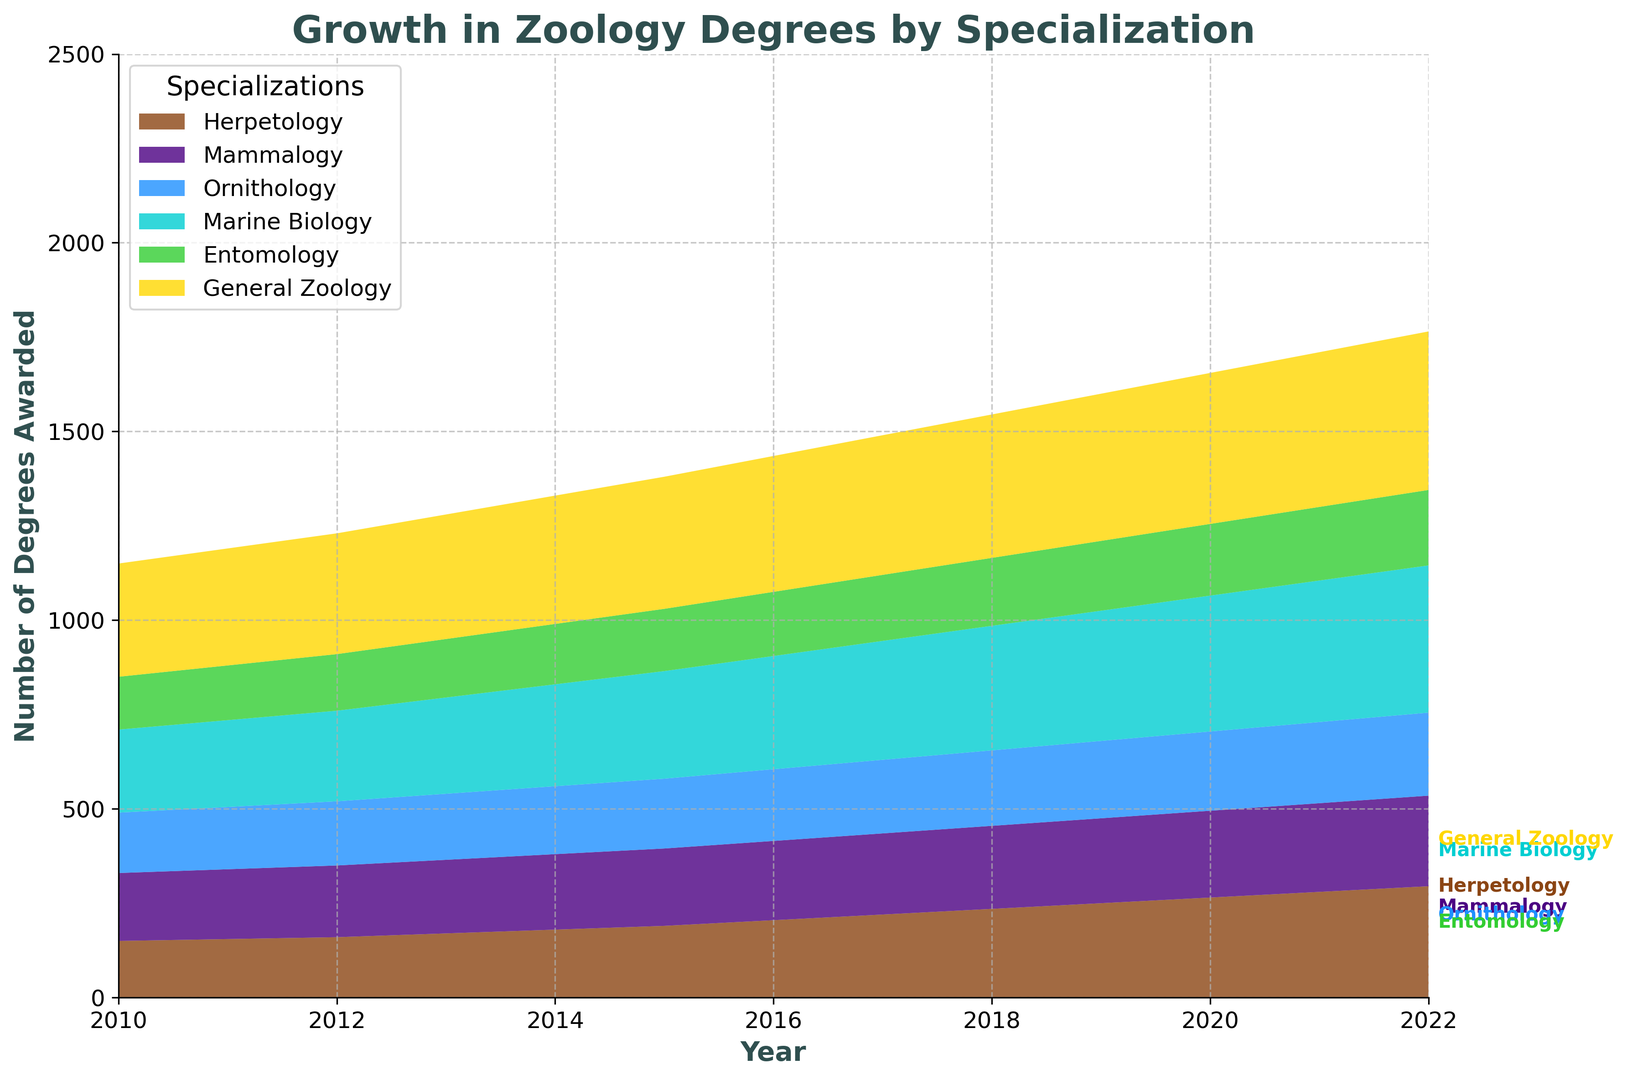What's the total number of degrees awarded in 2022 across all specializations? First, find the values for each specialization in 2022: Herpetology (295), Mammalogy (240), Ornithology (220), Marine Biology (390), Entomology (200), General Zoology (420). Sum these values: 295 + 240 + 220 + 390 + 200 + 420 = 1765
Answer: 1765 Which specialization showed the most significant growth from 2010 to 2022? Calculate the difference between the values in 2022 and 2010 for each specialization: Herpetology (295-150=145), Mammalogy (240-180=60), Ornithology (220-160=60), Marine Biology (390-220=170), Entomology (200-140=60), General Zoology (420-300=120). Marine Biology has the highest growth of 170
Answer: Marine Biology In which year did General Zoology first surpass 350 degrees awarded? Look at the values for General Zoology over the years and identify the first year the value is greater than 350: In 2015, General Zoology awarded 350 degrees and in 2016, it is 360. The first year it surpassed 350 was 2016
Answer: 2016 Comparing Marine Biology and Entomology, which specialization consistently awarded more degrees every year? Compare the values for Marine Biology and Entomology for each year from 2010 to 2022. In every year, the values for Marine Biology (e.g., 220 in 2010, 390 in 2022) are higher than those for Entomology (e.g., 140 in 2010, 200 in 2022)
Answer: Marine Biology What is the average number of degrees awarded annually in Mammalogy from 2010 to 2022? Sum the values from 2010 to 2022: 180 + 185 + 190 + 195 + 200 + 205 + 210 + 215 + 220 + 225 + 230 + 235 + 240 = 2730. There are 13 years, so the average is 2730 / 13 = 210
Answer: 210 Which specialization had the second highest number of degrees awarded in 2022? List the number of degrees awarded by specialization in 2022: Herpetology (295), Mammalogy (240), Ornithology (220), Marine Biology (390), Entomology (200), General Zoology (420). The highest is General Zoology (420), and the second highest is Marine Biology (390)
Answer: Marine Biology If you sum up all degrees awarded in Ornithology and Herpetology in 2018, what is the result? Add the values for Ornithology (200) and Herpetology (235) in 2018: 200 + 235 = 435
Answer: 435 In which years did Entomology award more than 150 but less than 200 degrees? Identify the years where Entomology's degrees fall between 150 and 200: These are the years 2012 (150), 2013 (155), 2014 (160), 2015 (165), 2016 (170), 2017 (175), 2018 (180), 2019 (185), 2020 (190), and 2021 (195)
Answer: 2012-2021 